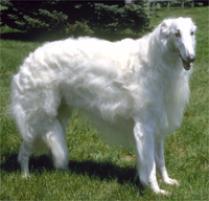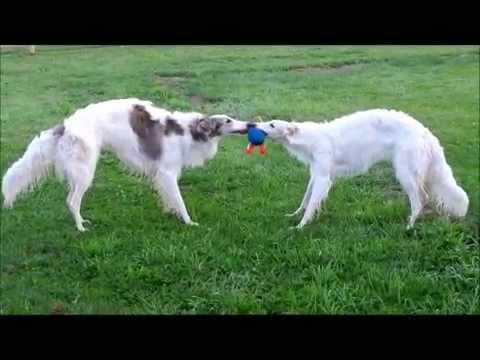The first image is the image on the left, the second image is the image on the right. Examine the images to the left and right. Is the description "An image shows exactly two hounds, which face one another." accurate? Answer yes or no. Yes. The first image is the image on the left, the second image is the image on the right. Evaluate the accuracy of this statement regarding the images: "One of the pictures contains two dogs.". Is it true? Answer yes or no. Yes. 